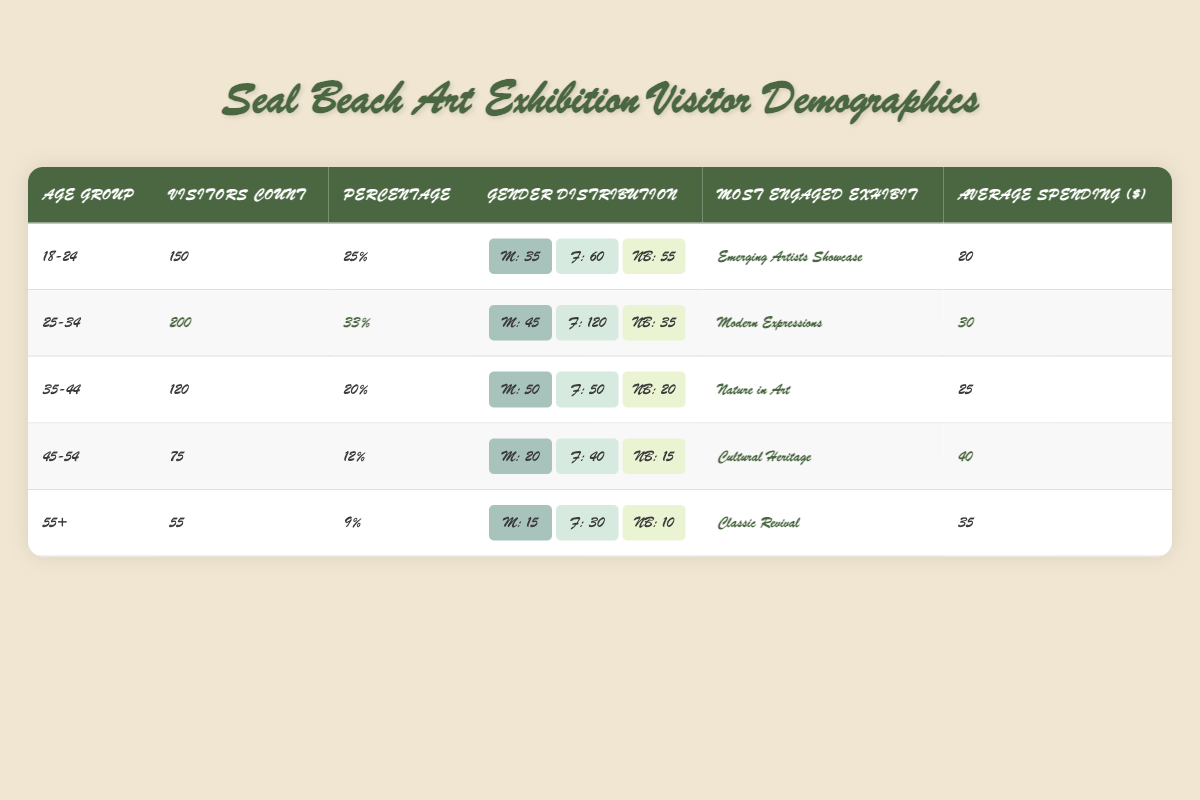What is the most visited age group? The age group with the highest visitor count is 25-34, with 200 visitors.
Answer: 25-34 Which age group has the highest average spending? The 45-54 age group has the highest average spending at $40.
Answer: 45-54 How many non-binary visitors were there in the 18-24 age group? The 18-24 age group has 55 non-binary visitors.
Answer: 55 What percentage of visitors were aged 55 and older? The percentage of visitors aged 55 and older is 9%.
Answer: 9% Is the most engaged exhibit for the 35-44 age group "Nature in Art"? Yes, "Nature in Art" is the most engaged exhibit for the 35-44 age group.
Answer: Yes What is the total number of visitors from the 25-34 and 35-44 age groups combined? The total number of visitors for the two age groups is 200 (25-34) + 120 (35-44) = 320.
Answer: 320 Which gender had the highest representation in the 25-34 age group? The female gender had the highest representation with 120 visitors.
Answer: Female How many visitors from the 45-54 age group spent less than $35 on average? The average spending for the 45-54 age group is $40; therefore, 75 visitors spent less than $35.
Answer: 75 Which gender is most predominant in the 18-24 age group? Females are the most predominant gender in the 18-24 age group, with 60 visitors.
Answer: Female If you combine the 18-24 and 25-34 age groups, what percentage of total visitors does that represent? The combined percentage is 25% (18-24) + 33% (25-34) = 58%.
Answer: 58% What is the difference in average spending between the 25-34 and 45-54 age groups? The average spending for the 25-34 age group is $30 and for the 45-54 age group is $40, so the difference is $40 - $30 = $10.
Answer: $10 